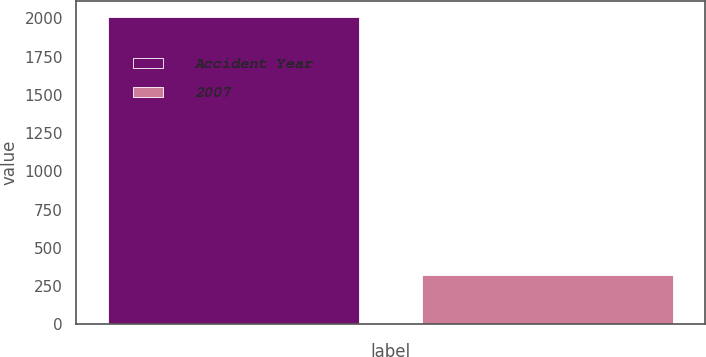<chart> <loc_0><loc_0><loc_500><loc_500><bar_chart><fcel>Accident Year<fcel>2007<nl><fcel>2011<fcel>322<nl></chart> 